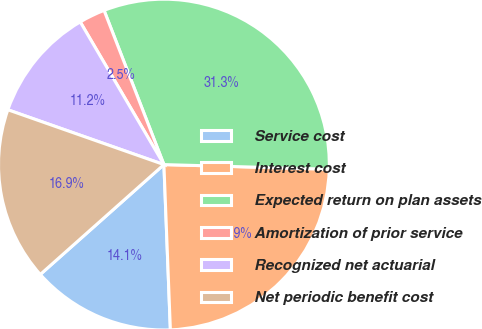<chart> <loc_0><loc_0><loc_500><loc_500><pie_chart><fcel>Service cost<fcel>Interest cost<fcel>Expected return on plan assets<fcel>Amortization of prior service<fcel>Recognized net actuarial<fcel>Net periodic benefit cost<nl><fcel>14.06%<fcel>23.93%<fcel>31.34%<fcel>2.55%<fcel>11.18%<fcel>16.94%<nl></chart> 